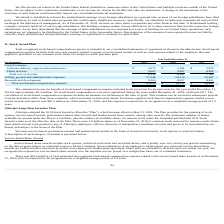According to Allscripts Healthcare Solutions's financial document, What is included in the stock-based compensation? includes both non-cash expense related to grants of stock-based awards as well as cash expense related to the employee discount applied to purchases of our common stock under our employee stock purchase plan.. The document states: "compensation expense includes both non-cash expense related to grants of stock-based awards as well as cash expense related to the employee discount a..." Also, What was the estimated income tax benefit of stock based compensation expense included in the provision for income taxes in 2019? According to the financial document, $5.3 million. The relevant text states: "2019 is approximately $5.3 million. No stock-based compensation costs were capitalized during the years ended December 31, 2019, 2018..." Also, What was the total unrecognized stock-based compensation expense in 2019? According to the financial document, $62.4 million. The relevant text states: "ense related to non- vested awards and options was $62.4 million as of December 31, 2019, and this expense is expected to be recognized over a weighted-average perio..." Also, can you calculate: What was the change in the Software delivery, support and maintenance value from 2018 to 2019? Based on the calculation: 2,075 - 2,184, the result is -109 (in thousands). This is based on the information: "Software delivery, support and maintenance $ 2,075 $ 2,184 $ 2,879 tware delivery, support and maintenance $ 2,075 $ 2,184 $ 2,879..." The key data points involved are: 2,075, 2,184. Also, can you calculate: What is the average Client services for 2017-2019? To answer this question, I need to perform calculations using the financial data. The calculation is: (4,067 + 3,997 + 4,484) / 3, which equals 4182.67 (in thousands). This is based on the information: "Client services 4,067 3,997 4,484 Client services 4,067 3,997 4,484 Client services 4,067 3,997 4,484..." The key data points involved are: 3,997, 4,067, 4,484. Also, can you calculate: What is the change in the Total cost of revenue from 2018 to 2019? Based on the calculation: 6,142 - 6,181, the result is -39 (in thousands). This is based on the information: "Total cost of revenue 6,142 6,181 7,363 Total cost of revenue 6,142 6,181 7,363..." The key data points involved are: 6,142, 6,181. 